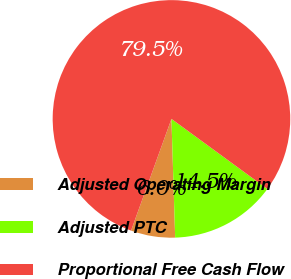Convert chart to OTSL. <chart><loc_0><loc_0><loc_500><loc_500><pie_chart><fcel>Adjusted Operating Margin<fcel>Adjusted PTC<fcel>Proportional Free Cash Flow<nl><fcel>6.02%<fcel>14.46%<fcel>79.52%<nl></chart> 